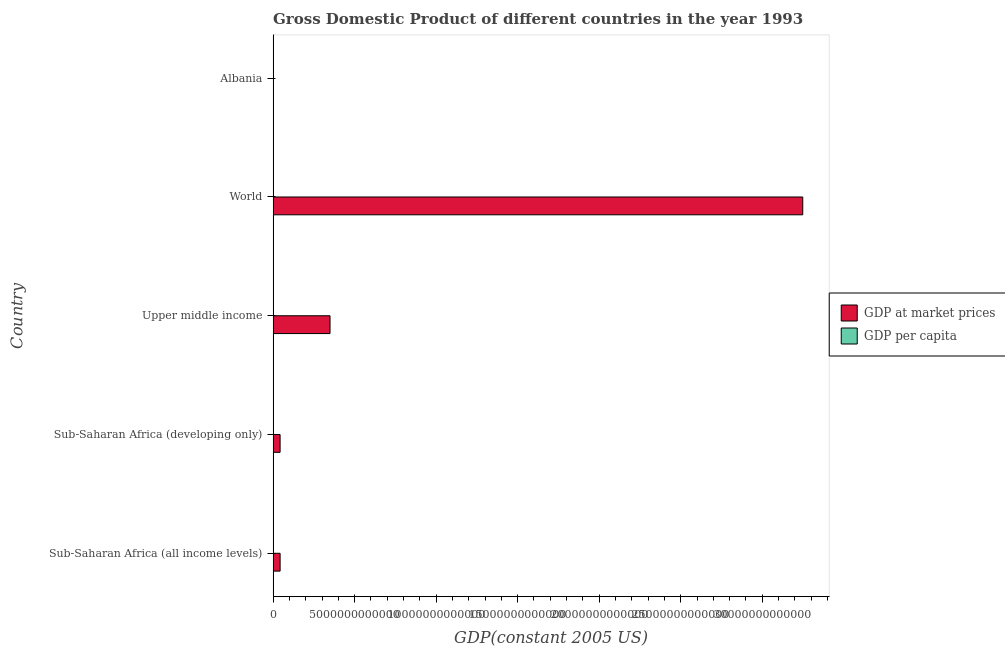How many different coloured bars are there?
Make the answer very short. 2. How many groups of bars are there?
Provide a succinct answer. 5. How many bars are there on the 4th tick from the top?
Offer a very short reply. 2. What is the gdp at market prices in Sub-Saharan Africa (developing only)?
Give a very brief answer. 4.28e+11. Across all countries, what is the maximum gdp per capita?
Provide a short and direct response. 5866.55. Across all countries, what is the minimum gdp at market prices?
Ensure brevity in your answer.  3.89e+09. In which country was the gdp at market prices maximum?
Your answer should be very brief. World. In which country was the gdp per capita minimum?
Offer a very short reply. Sub-Saharan Africa (developing only). What is the total gdp at market prices in the graph?
Keep it short and to the point. 3.68e+13. What is the difference between the gdp at market prices in Albania and that in Sub-Saharan Africa (developing only)?
Make the answer very short. -4.24e+11. What is the difference between the gdp per capita in Sub-Saharan Africa (all income levels) and the gdp at market prices in Upper middle income?
Give a very brief answer. -3.49e+12. What is the average gdp per capita per country?
Your response must be concise. 2085.29. What is the difference between the gdp at market prices and gdp per capita in World?
Keep it short and to the point. 3.25e+13. In how many countries, is the gdp at market prices greater than 29000000000000 US$?
Make the answer very short. 1. What is the ratio of the gdp per capita in Albania to that in Sub-Saharan Africa (all income levels)?
Your answer should be very brief. 1.56. Is the difference between the gdp per capita in Sub-Saharan Africa (all income levels) and Sub-Saharan Africa (developing only) greater than the difference between the gdp at market prices in Sub-Saharan Africa (all income levels) and Sub-Saharan Africa (developing only)?
Provide a succinct answer. No. What is the difference between the highest and the second highest gdp at market prices?
Your response must be concise. 2.90e+13. What is the difference between the highest and the lowest gdp at market prices?
Give a very brief answer. 3.25e+13. In how many countries, is the gdp per capita greater than the average gdp per capita taken over all countries?
Your response must be concise. 1. What does the 2nd bar from the top in Sub-Saharan Africa (all income levels) represents?
Provide a short and direct response. GDP at market prices. What does the 1st bar from the bottom in Albania represents?
Offer a very short reply. GDP at market prices. Are all the bars in the graph horizontal?
Offer a very short reply. Yes. What is the difference between two consecutive major ticks on the X-axis?
Keep it short and to the point. 5.00e+12. Are the values on the major ticks of X-axis written in scientific E-notation?
Provide a succinct answer. No. Does the graph contain grids?
Give a very brief answer. No. How many legend labels are there?
Give a very brief answer. 2. How are the legend labels stacked?
Your response must be concise. Vertical. What is the title of the graph?
Keep it short and to the point. Gross Domestic Product of different countries in the year 1993. Does "Ages 15-24" appear as one of the legend labels in the graph?
Offer a terse response. No. What is the label or title of the X-axis?
Give a very brief answer. GDP(constant 2005 US). What is the label or title of the Y-axis?
Your answer should be very brief. Country. What is the GDP(constant 2005 US) in GDP at market prices in Sub-Saharan Africa (all income levels)?
Offer a terse response. 4.29e+11. What is the GDP(constant 2005 US) in GDP per capita in Sub-Saharan Africa (all income levels)?
Your answer should be compact. 775.18. What is the GDP(constant 2005 US) of GDP at market prices in Sub-Saharan Africa (developing only)?
Provide a succinct answer. 4.28e+11. What is the GDP(constant 2005 US) in GDP per capita in Sub-Saharan Africa (developing only)?
Offer a terse response. 774.69. What is the GDP(constant 2005 US) in GDP at market prices in Upper middle income?
Your answer should be very brief. 3.49e+12. What is the GDP(constant 2005 US) in GDP per capita in Upper middle income?
Make the answer very short. 1803.35. What is the GDP(constant 2005 US) in GDP at market prices in World?
Ensure brevity in your answer.  3.25e+13. What is the GDP(constant 2005 US) in GDP per capita in World?
Keep it short and to the point. 5866.55. What is the GDP(constant 2005 US) of GDP at market prices in Albania?
Provide a short and direct response. 3.89e+09. What is the GDP(constant 2005 US) in GDP per capita in Albania?
Your answer should be compact. 1206.67. Across all countries, what is the maximum GDP(constant 2005 US) of GDP at market prices?
Provide a short and direct response. 3.25e+13. Across all countries, what is the maximum GDP(constant 2005 US) in GDP per capita?
Your response must be concise. 5866.55. Across all countries, what is the minimum GDP(constant 2005 US) of GDP at market prices?
Provide a short and direct response. 3.89e+09. Across all countries, what is the minimum GDP(constant 2005 US) of GDP per capita?
Your answer should be compact. 774.69. What is the total GDP(constant 2005 US) of GDP at market prices in the graph?
Your answer should be very brief. 3.68e+13. What is the total GDP(constant 2005 US) of GDP per capita in the graph?
Give a very brief answer. 1.04e+04. What is the difference between the GDP(constant 2005 US) of GDP at market prices in Sub-Saharan Africa (all income levels) and that in Sub-Saharan Africa (developing only)?
Give a very brief answer. 6.51e+08. What is the difference between the GDP(constant 2005 US) of GDP per capita in Sub-Saharan Africa (all income levels) and that in Sub-Saharan Africa (developing only)?
Ensure brevity in your answer.  0.49. What is the difference between the GDP(constant 2005 US) in GDP at market prices in Sub-Saharan Africa (all income levels) and that in Upper middle income?
Your answer should be very brief. -3.06e+12. What is the difference between the GDP(constant 2005 US) in GDP per capita in Sub-Saharan Africa (all income levels) and that in Upper middle income?
Provide a succinct answer. -1028.17. What is the difference between the GDP(constant 2005 US) of GDP at market prices in Sub-Saharan Africa (all income levels) and that in World?
Make the answer very short. -3.21e+13. What is the difference between the GDP(constant 2005 US) of GDP per capita in Sub-Saharan Africa (all income levels) and that in World?
Your answer should be very brief. -5091.37. What is the difference between the GDP(constant 2005 US) in GDP at market prices in Sub-Saharan Africa (all income levels) and that in Albania?
Provide a succinct answer. 4.25e+11. What is the difference between the GDP(constant 2005 US) of GDP per capita in Sub-Saharan Africa (all income levels) and that in Albania?
Provide a short and direct response. -431.48. What is the difference between the GDP(constant 2005 US) in GDP at market prices in Sub-Saharan Africa (developing only) and that in Upper middle income?
Ensure brevity in your answer.  -3.06e+12. What is the difference between the GDP(constant 2005 US) of GDP per capita in Sub-Saharan Africa (developing only) and that in Upper middle income?
Offer a very short reply. -1028.66. What is the difference between the GDP(constant 2005 US) of GDP at market prices in Sub-Saharan Africa (developing only) and that in World?
Offer a very short reply. -3.21e+13. What is the difference between the GDP(constant 2005 US) in GDP per capita in Sub-Saharan Africa (developing only) and that in World?
Give a very brief answer. -5091.86. What is the difference between the GDP(constant 2005 US) of GDP at market prices in Sub-Saharan Africa (developing only) and that in Albania?
Keep it short and to the point. 4.24e+11. What is the difference between the GDP(constant 2005 US) of GDP per capita in Sub-Saharan Africa (developing only) and that in Albania?
Make the answer very short. -431.97. What is the difference between the GDP(constant 2005 US) of GDP at market prices in Upper middle income and that in World?
Offer a very short reply. -2.90e+13. What is the difference between the GDP(constant 2005 US) in GDP per capita in Upper middle income and that in World?
Give a very brief answer. -4063.2. What is the difference between the GDP(constant 2005 US) in GDP at market prices in Upper middle income and that in Albania?
Make the answer very short. 3.49e+12. What is the difference between the GDP(constant 2005 US) in GDP per capita in Upper middle income and that in Albania?
Offer a very short reply. 596.68. What is the difference between the GDP(constant 2005 US) in GDP at market prices in World and that in Albania?
Make the answer very short. 3.25e+13. What is the difference between the GDP(constant 2005 US) in GDP per capita in World and that in Albania?
Your answer should be very brief. 4659.89. What is the difference between the GDP(constant 2005 US) in GDP at market prices in Sub-Saharan Africa (all income levels) and the GDP(constant 2005 US) in GDP per capita in Sub-Saharan Africa (developing only)?
Your answer should be compact. 4.29e+11. What is the difference between the GDP(constant 2005 US) in GDP at market prices in Sub-Saharan Africa (all income levels) and the GDP(constant 2005 US) in GDP per capita in Upper middle income?
Provide a succinct answer. 4.29e+11. What is the difference between the GDP(constant 2005 US) in GDP at market prices in Sub-Saharan Africa (all income levels) and the GDP(constant 2005 US) in GDP per capita in World?
Offer a terse response. 4.29e+11. What is the difference between the GDP(constant 2005 US) of GDP at market prices in Sub-Saharan Africa (all income levels) and the GDP(constant 2005 US) of GDP per capita in Albania?
Your response must be concise. 4.29e+11. What is the difference between the GDP(constant 2005 US) in GDP at market prices in Sub-Saharan Africa (developing only) and the GDP(constant 2005 US) in GDP per capita in Upper middle income?
Offer a very short reply. 4.28e+11. What is the difference between the GDP(constant 2005 US) of GDP at market prices in Sub-Saharan Africa (developing only) and the GDP(constant 2005 US) of GDP per capita in World?
Provide a succinct answer. 4.28e+11. What is the difference between the GDP(constant 2005 US) in GDP at market prices in Sub-Saharan Africa (developing only) and the GDP(constant 2005 US) in GDP per capita in Albania?
Your answer should be very brief. 4.28e+11. What is the difference between the GDP(constant 2005 US) of GDP at market prices in Upper middle income and the GDP(constant 2005 US) of GDP per capita in World?
Provide a succinct answer. 3.49e+12. What is the difference between the GDP(constant 2005 US) of GDP at market prices in Upper middle income and the GDP(constant 2005 US) of GDP per capita in Albania?
Keep it short and to the point. 3.49e+12. What is the difference between the GDP(constant 2005 US) of GDP at market prices in World and the GDP(constant 2005 US) of GDP per capita in Albania?
Make the answer very short. 3.25e+13. What is the average GDP(constant 2005 US) in GDP at market prices per country?
Give a very brief answer. 7.37e+12. What is the average GDP(constant 2005 US) of GDP per capita per country?
Provide a succinct answer. 2085.29. What is the difference between the GDP(constant 2005 US) of GDP at market prices and GDP(constant 2005 US) of GDP per capita in Sub-Saharan Africa (all income levels)?
Make the answer very short. 4.29e+11. What is the difference between the GDP(constant 2005 US) of GDP at market prices and GDP(constant 2005 US) of GDP per capita in Sub-Saharan Africa (developing only)?
Provide a short and direct response. 4.28e+11. What is the difference between the GDP(constant 2005 US) of GDP at market prices and GDP(constant 2005 US) of GDP per capita in Upper middle income?
Your answer should be compact. 3.49e+12. What is the difference between the GDP(constant 2005 US) in GDP at market prices and GDP(constant 2005 US) in GDP per capita in World?
Your answer should be compact. 3.25e+13. What is the difference between the GDP(constant 2005 US) in GDP at market prices and GDP(constant 2005 US) in GDP per capita in Albania?
Keep it short and to the point. 3.89e+09. What is the ratio of the GDP(constant 2005 US) of GDP per capita in Sub-Saharan Africa (all income levels) to that in Sub-Saharan Africa (developing only)?
Provide a succinct answer. 1. What is the ratio of the GDP(constant 2005 US) of GDP at market prices in Sub-Saharan Africa (all income levels) to that in Upper middle income?
Keep it short and to the point. 0.12. What is the ratio of the GDP(constant 2005 US) in GDP per capita in Sub-Saharan Africa (all income levels) to that in Upper middle income?
Your response must be concise. 0.43. What is the ratio of the GDP(constant 2005 US) of GDP at market prices in Sub-Saharan Africa (all income levels) to that in World?
Offer a terse response. 0.01. What is the ratio of the GDP(constant 2005 US) in GDP per capita in Sub-Saharan Africa (all income levels) to that in World?
Offer a terse response. 0.13. What is the ratio of the GDP(constant 2005 US) in GDP at market prices in Sub-Saharan Africa (all income levels) to that in Albania?
Your response must be concise. 110.05. What is the ratio of the GDP(constant 2005 US) in GDP per capita in Sub-Saharan Africa (all income levels) to that in Albania?
Your response must be concise. 0.64. What is the ratio of the GDP(constant 2005 US) of GDP at market prices in Sub-Saharan Africa (developing only) to that in Upper middle income?
Make the answer very short. 0.12. What is the ratio of the GDP(constant 2005 US) of GDP per capita in Sub-Saharan Africa (developing only) to that in Upper middle income?
Keep it short and to the point. 0.43. What is the ratio of the GDP(constant 2005 US) in GDP at market prices in Sub-Saharan Africa (developing only) to that in World?
Make the answer very short. 0.01. What is the ratio of the GDP(constant 2005 US) of GDP per capita in Sub-Saharan Africa (developing only) to that in World?
Keep it short and to the point. 0.13. What is the ratio of the GDP(constant 2005 US) in GDP at market prices in Sub-Saharan Africa (developing only) to that in Albania?
Ensure brevity in your answer.  109.88. What is the ratio of the GDP(constant 2005 US) in GDP per capita in Sub-Saharan Africa (developing only) to that in Albania?
Your answer should be compact. 0.64. What is the ratio of the GDP(constant 2005 US) in GDP at market prices in Upper middle income to that in World?
Provide a succinct answer. 0.11. What is the ratio of the GDP(constant 2005 US) in GDP per capita in Upper middle income to that in World?
Your answer should be compact. 0.31. What is the ratio of the GDP(constant 2005 US) in GDP at market prices in Upper middle income to that in Albania?
Give a very brief answer. 896.31. What is the ratio of the GDP(constant 2005 US) of GDP per capita in Upper middle income to that in Albania?
Keep it short and to the point. 1.49. What is the ratio of the GDP(constant 2005 US) in GDP at market prices in World to that in Albania?
Keep it short and to the point. 8342.18. What is the ratio of the GDP(constant 2005 US) of GDP per capita in World to that in Albania?
Provide a succinct answer. 4.86. What is the difference between the highest and the second highest GDP(constant 2005 US) in GDP at market prices?
Keep it short and to the point. 2.90e+13. What is the difference between the highest and the second highest GDP(constant 2005 US) of GDP per capita?
Your answer should be very brief. 4063.2. What is the difference between the highest and the lowest GDP(constant 2005 US) in GDP at market prices?
Provide a succinct answer. 3.25e+13. What is the difference between the highest and the lowest GDP(constant 2005 US) of GDP per capita?
Your answer should be very brief. 5091.86. 